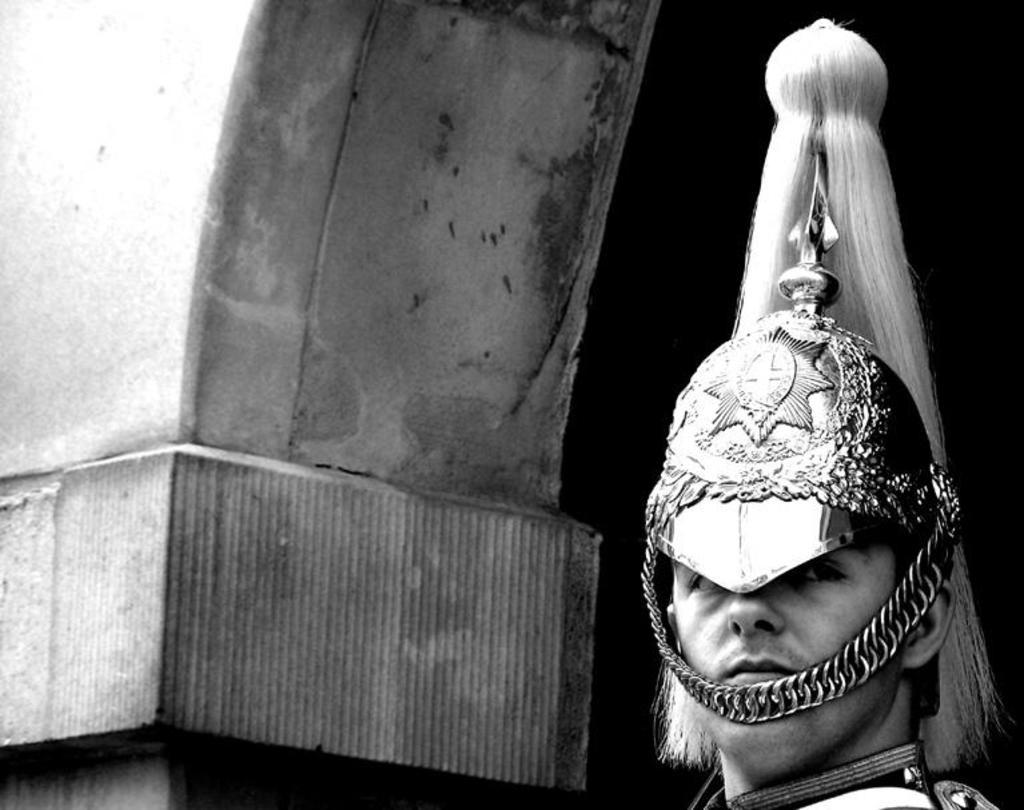Who or what is present in the image? There is a person in the image. What is the person wearing on his head? The person is wearing a crown on his head. What is the color scheme of the image? The image is black and white. What can be seen on the left side of the image? There is a wall on the left side of the image. Can you see any patches on the person's clothing in the image? There is no mention of patches on the person's clothing in the provided facts, so we cannot determine their presence from the image. 